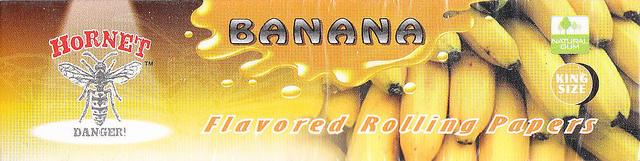Is there a bee?
Short answer required. Yes. What brand are the rolling papers?
Be succinct. Hornet. What flavor are the rolling papers?
Write a very short answer. Banana. 